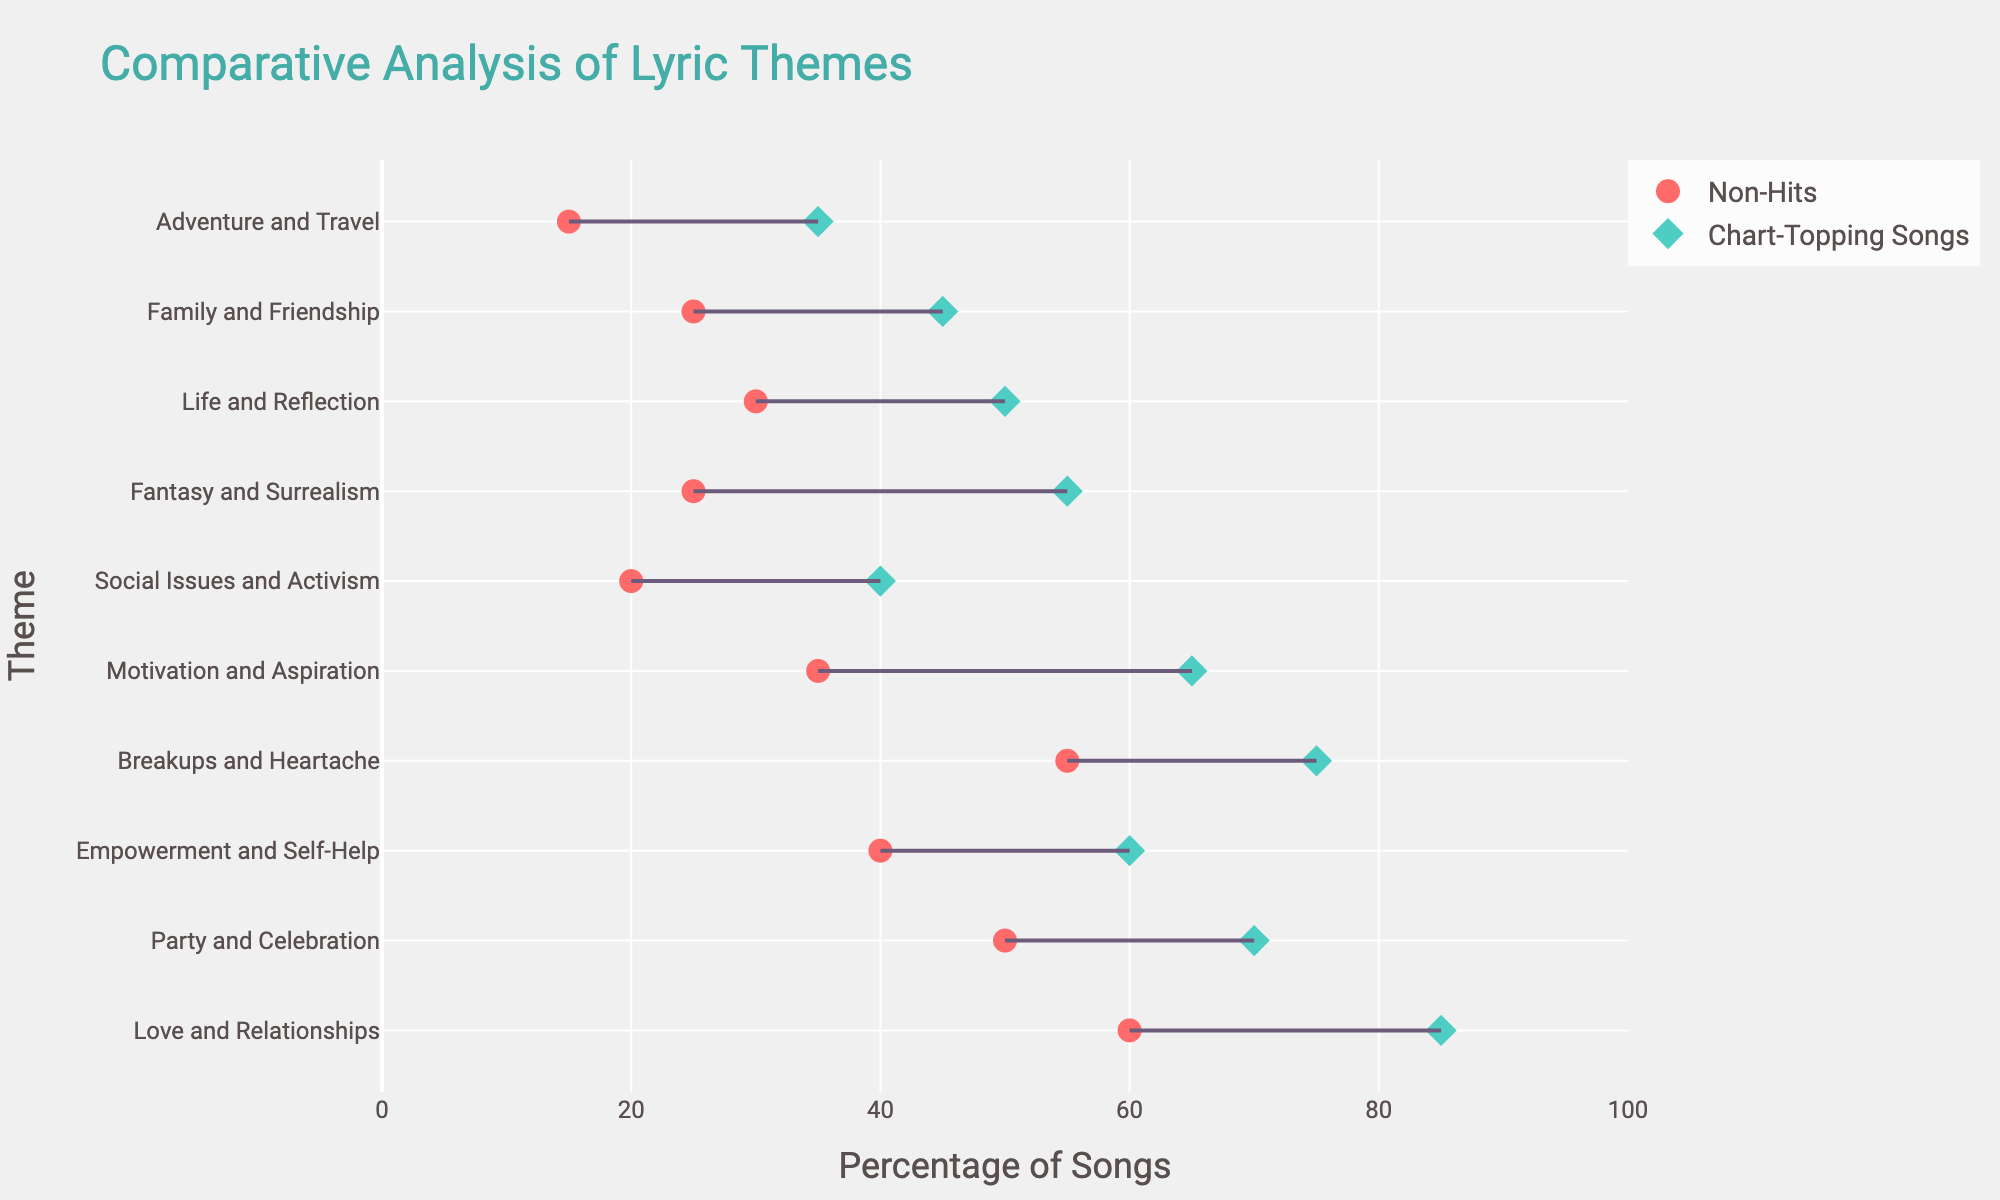What theme has the highest percentage of chart-topping songs? Look for the dot representing chart-topping songs on the x-axis with the highest percentage; it’s at 85%. The corresponding theme is "Love and Relationships".
Answer: Love and Relationships What is the percentage difference in the theme "Fantasy and Surrealism" between chart-topping songs and non-hits? Subtract the percentage for non-hits from the percentage for chart-topping songs for "Fantasy and Surrealism": 55% - 25% = 30%.
Answer: 30% Which theme shows the smallest percentage difference between chart-topping songs and non-hits? Calculate the percentage difference for each theme and find the smallest value. For "Family and Friendship": 45% - 25% is 20%, which is the smallest.
Answer: Family and Friendship Do more chart-topping songs or non-hits talk about social issues and activism? Compare the x-axis positions of the two markers for "Social Issues and Activism". The chart-topping song marker is at 40% while the non-hits marker is at 20%.
Answer: Chart-topping songs What is the median percentage for the chart-topping song themes? List percentages for chart-topping themes: 85, 70, 60, 75, 65, 40, 55, 50, 45, 35. The median is the average of the two middle numbers: (60+65)/2 = 62.5.
Answer: 62.5 Which theme has the lowest frequency among non-hits? Identify the lowest percentage value for non-hits, which is at 15%. The corresponding theme is "Adventure and Travel".
Answer: Adventure and Travel By how much is the percentage of non-hits with "Life and Reflection" themes lower than the chart-topping songs’? Subtract the percentage of non-hits from the chart-topping songs for "Life and Reflection": 50% - 30% = 20%.
Answer: 20% Do we see a trend where themes are generally more frequent in chart-topping songs compared to non-hits? Look at the lines connecting markers: most lines go from lower percentages (non-hits) to higher percentages (chart-topping), indicating a general trend.
Answer: Yes Which theme has an equal or nearly equal percentage for both chart-topping songs and non-hits? Check differences; None of the themes have equal percentages, but the smallest difference is with "Family and Friendship" (45%-25%).
Answer: None How much higher is the percentage of chart-topping songs with "Breakups and Heartache" themes compared to non-hits? Subtract the percentage of non-hits from chart-topping songs for "Breakups and Heartache": 75% - 55% = 20%.
Answer: 20% 